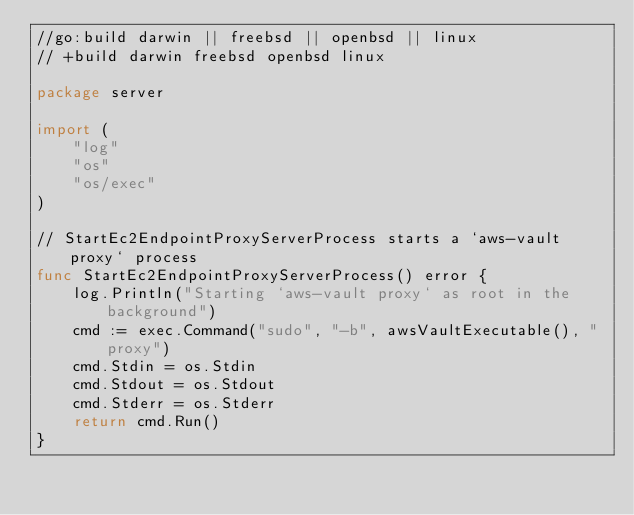<code> <loc_0><loc_0><loc_500><loc_500><_Go_>//go:build darwin || freebsd || openbsd || linux
// +build darwin freebsd openbsd linux

package server

import (
	"log"
	"os"
	"os/exec"
)

// StartEc2EndpointProxyServerProcess starts a `aws-vault proxy` process
func StartEc2EndpointProxyServerProcess() error {
	log.Println("Starting `aws-vault proxy` as root in the background")
	cmd := exec.Command("sudo", "-b", awsVaultExecutable(), "proxy")
	cmd.Stdin = os.Stdin
	cmd.Stdout = os.Stdout
	cmd.Stderr = os.Stderr
	return cmd.Run()
}
</code> 